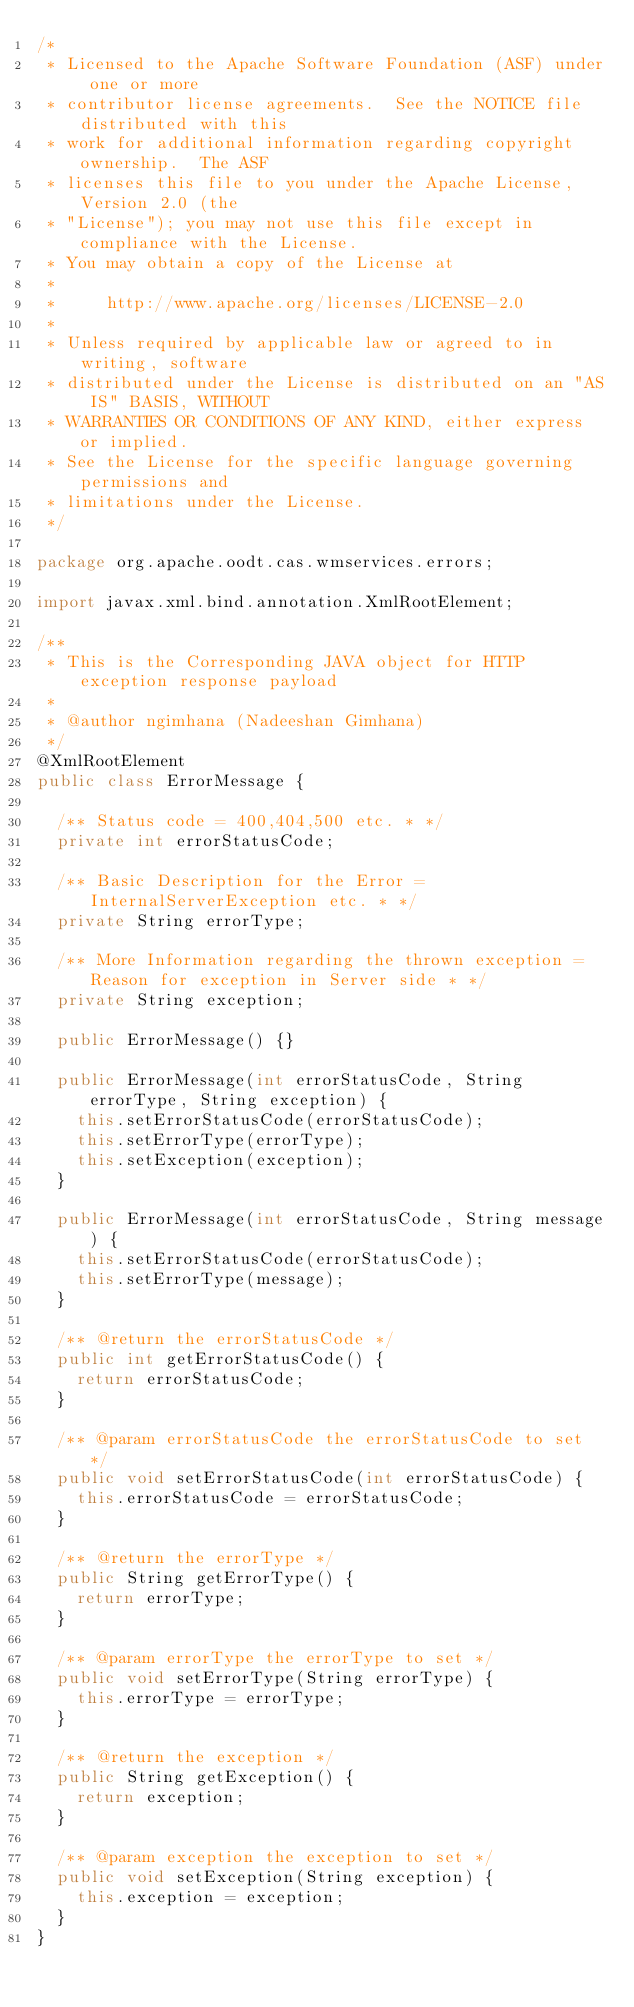<code> <loc_0><loc_0><loc_500><loc_500><_Java_>/*
 * Licensed to the Apache Software Foundation (ASF) under one or more
 * contributor license agreements.  See the NOTICE file distributed with this
 * work for additional information regarding copyright ownership.  The ASF
 * licenses this file to you under the Apache License, Version 2.0 (the
 * "License"); you may not use this file except in compliance with the License.
 * You may obtain a copy of the License at
 *
 *     http://www.apache.org/licenses/LICENSE-2.0
 *
 * Unless required by applicable law or agreed to in writing, software
 * distributed under the License is distributed on an "AS IS" BASIS, WITHOUT
 * WARRANTIES OR CONDITIONS OF ANY KIND, either express or implied.
 * See the License for the specific language governing permissions and
 * limitations under the License.
 */

package org.apache.oodt.cas.wmservices.errors;

import javax.xml.bind.annotation.XmlRootElement;

/**
 * This is the Corresponding JAVA object for HTTP exception response payload
 *
 * @author ngimhana (Nadeeshan Gimhana)
 */
@XmlRootElement
public class ErrorMessage {

  /** Status code = 400,404,500 etc. * */
  private int errorStatusCode;

  /** Basic Description for the Error = InternalServerException etc. * */
  private String errorType;

  /** More Information regarding the thrown exception = Reason for exception in Server side * */
  private String exception;

  public ErrorMessage() {}

  public ErrorMessage(int errorStatusCode, String errorType, String exception) {
    this.setErrorStatusCode(errorStatusCode);
    this.setErrorType(errorType);
    this.setException(exception);
  }

  public ErrorMessage(int errorStatusCode, String message) {
    this.setErrorStatusCode(errorStatusCode);
    this.setErrorType(message);
  }

  /** @return the errorStatusCode */
  public int getErrorStatusCode() {
    return errorStatusCode;
  }

  /** @param errorStatusCode the errorStatusCode to set */
  public void setErrorStatusCode(int errorStatusCode) {
    this.errorStatusCode = errorStatusCode;
  }

  /** @return the errorType */
  public String getErrorType() {
    return errorType;
  }

  /** @param errorType the errorType to set */
  public void setErrorType(String errorType) {
    this.errorType = errorType;
  }

  /** @return the exception */
  public String getException() {
    return exception;
  }

  /** @param exception the exception to set */
  public void setException(String exception) {
    this.exception = exception;
  }
}
</code> 